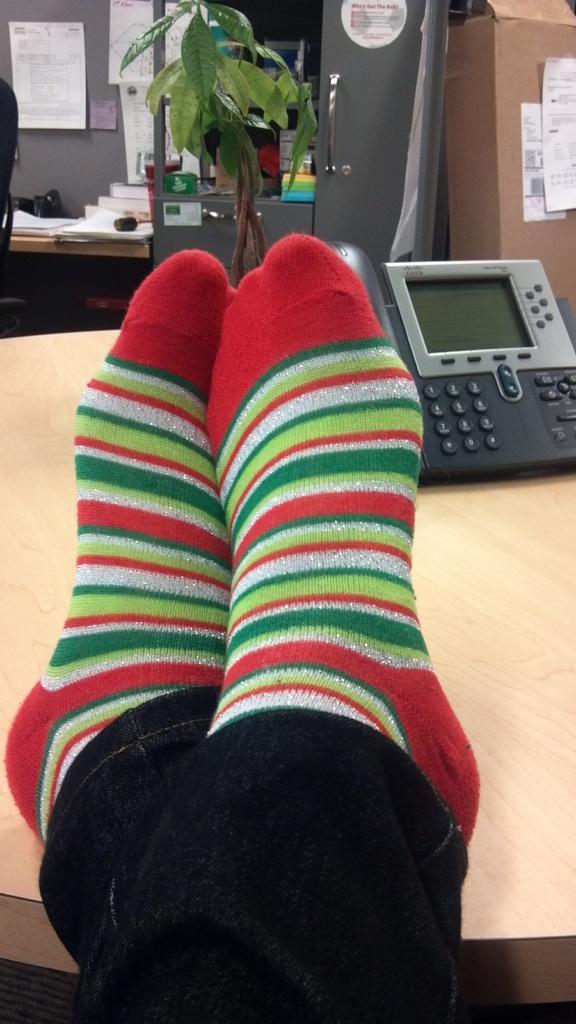How would you summarize this image in a sentence or two? In this image, I can see the legs of a person with socks and a telephone on the table. In the background, there is a plant, posters to the wall, books on the table, cupboard with few objects and a cardboard box. 